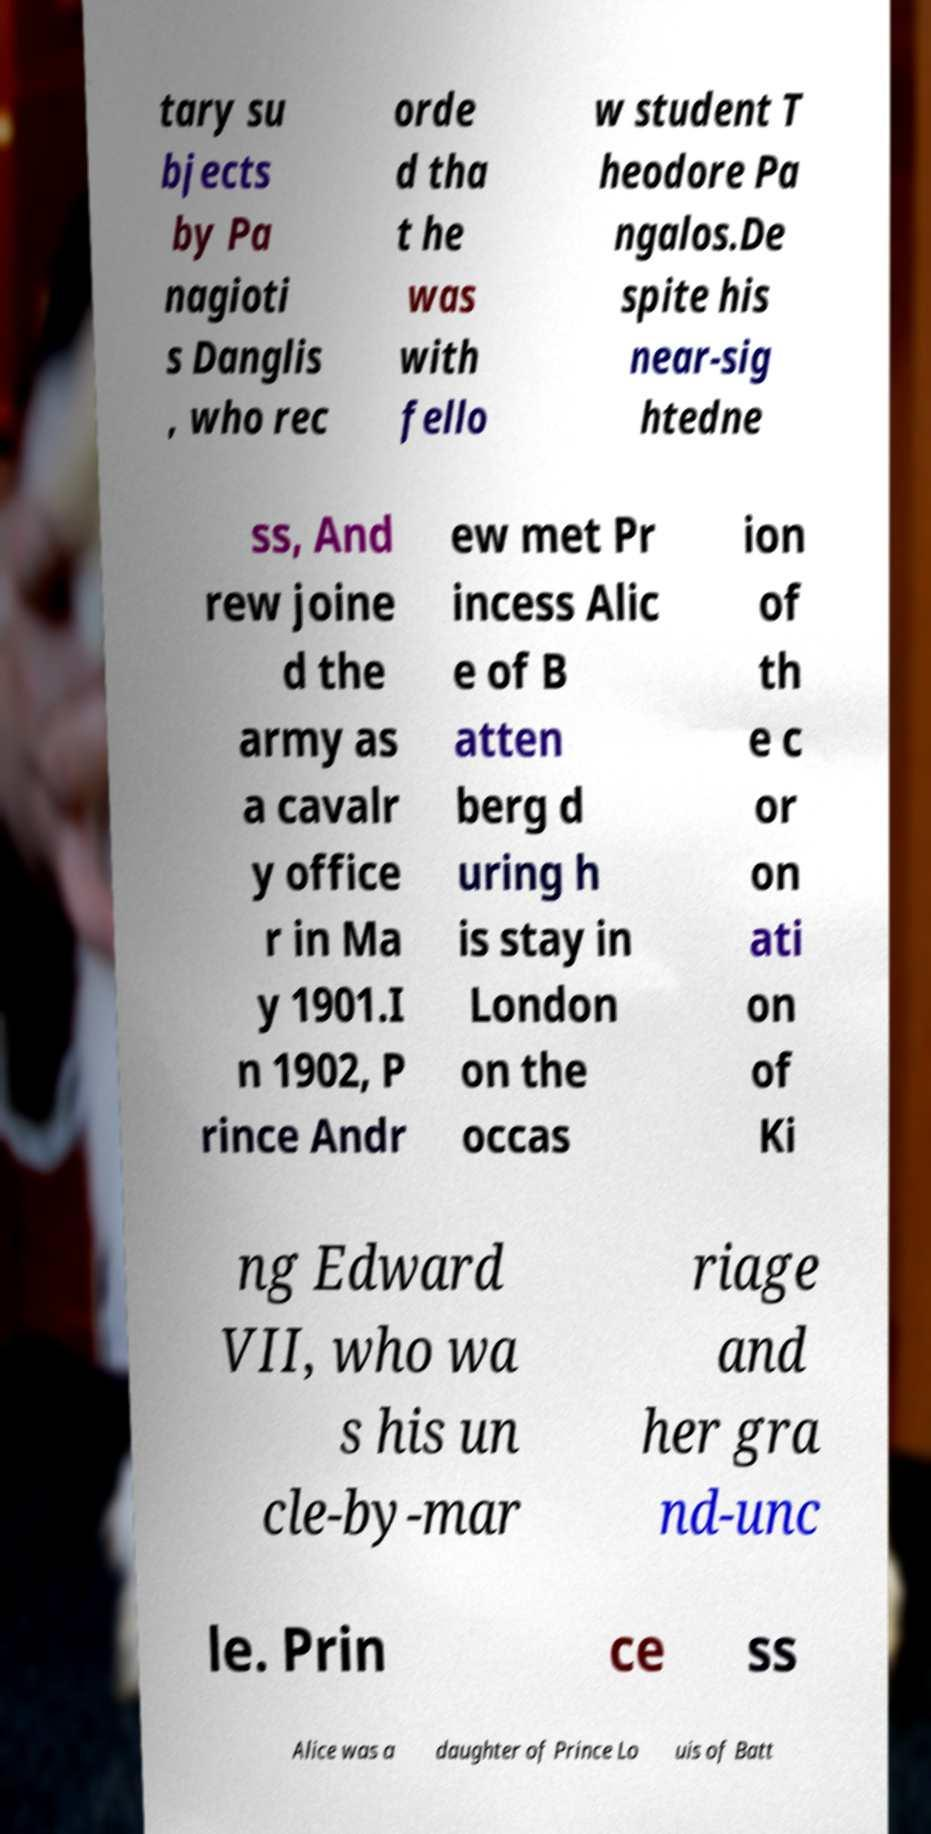Could you extract and type out the text from this image? tary su bjects by Pa nagioti s Danglis , who rec orde d tha t he was with fello w student T heodore Pa ngalos.De spite his near-sig htedne ss, And rew joine d the army as a cavalr y office r in Ma y 1901.I n 1902, P rince Andr ew met Pr incess Alic e of B atten berg d uring h is stay in London on the occas ion of th e c or on ati on of Ki ng Edward VII, who wa s his un cle-by-mar riage and her gra nd-unc le. Prin ce ss Alice was a daughter of Prince Lo uis of Batt 